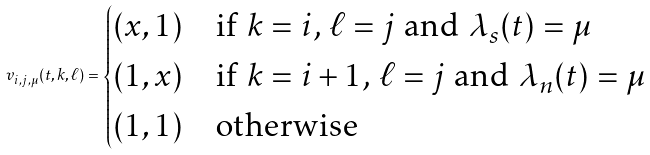Convert formula to latex. <formula><loc_0><loc_0><loc_500><loc_500>v _ { i , j , \mu } ( t , k , \ell ) = \begin{cases} ( x , 1 ) & \text {if $k = i$, $\ell = j$ and $\lambda_{s}(t) = \mu$} \\ ( 1 , x ) & \text {if $k = i+1$, $\ell = j$ and $\lambda_{n}(t) = \mu$} \\ ( 1 , 1 ) & \text {otherwise} \end{cases}</formula> 